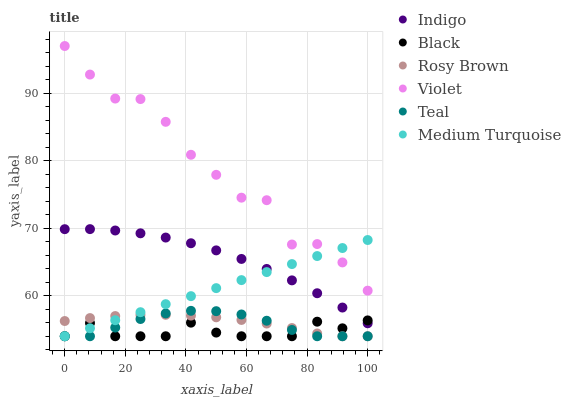Does Black have the minimum area under the curve?
Answer yes or no. Yes. Does Violet have the maximum area under the curve?
Answer yes or no. Yes. Does Teal have the minimum area under the curve?
Answer yes or no. No. Does Teal have the maximum area under the curve?
Answer yes or no. No. Is Medium Turquoise the smoothest?
Answer yes or no. Yes. Is Violet the roughest?
Answer yes or no. Yes. Is Teal the smoothest?
Answer yes or no. No. Is Teal the roughest?
Answer yes or no. No. Does Teal have the lowest value?
Answer yes or no. Yes. Does Violet have the lowest value?
Answer yes or no. No. Does Violet have the highest value?
Answer yes or no. Yes. Does Teal have the highest value?
Answer yes or no. No. Is Teal less than Indigo?
Answer yes or no. Yes. Is Indigo greater than Rosy Brown?
Answer yes or no. Yes. Does Medium Turquoise intersect Black?
Answer yes or no. Yes. Is Medium Turquoise less than Black?
Answer yes or no. No. Is Medium Turquoise greater than Black?
Answer yes or no. No. Does Teal intersect Indigo?
Answer yes or no. No. 